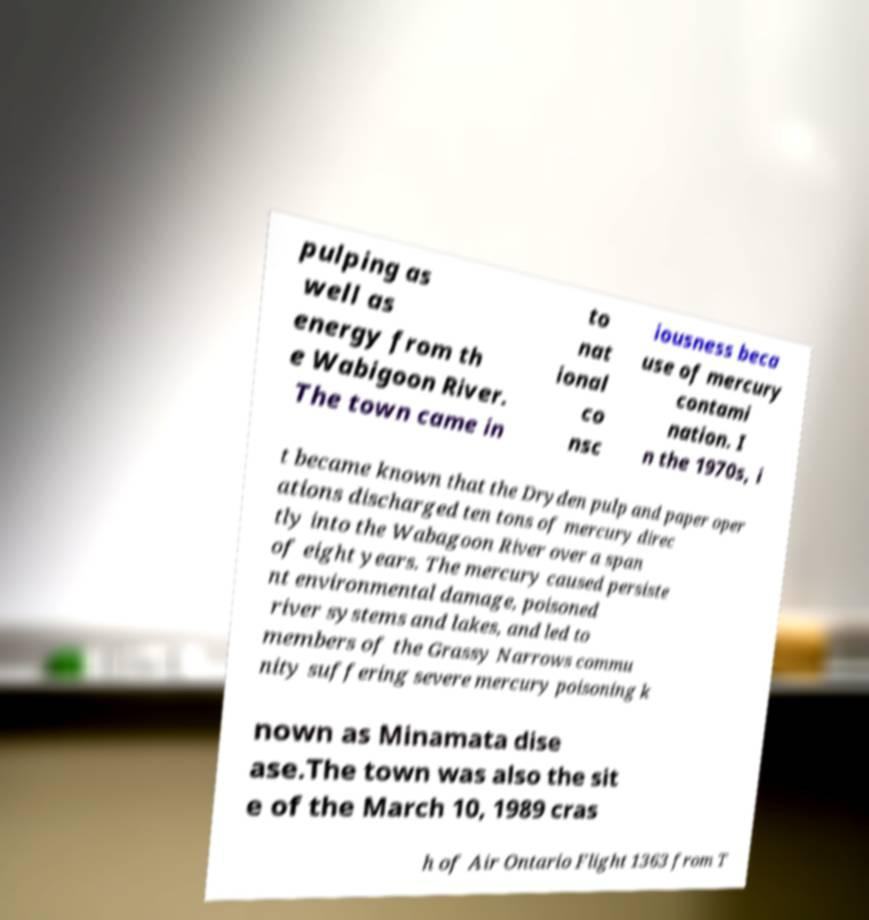Could you extract and type out the text from this image? pulping as well as energy from th e Wabigoon River. The town came in to nat ional co nsc iousness beca use of mercury contami nation. I n the 1970s, i t became known that the Dryden pulp and paper oper ations discharged ten tons of mercury direc tly into the Wabagoon River over a span of eight years. The mercury caused persiste nt environmental damage, poisoned river systems and lakes, and led to members of the Grassy Narrows commu nity suffering severe mercury poisoning k nown as Minamata dise ase.The town was also the sit e of the March 10, 1989 cras h of Air Ontario Flight 1363 from T 